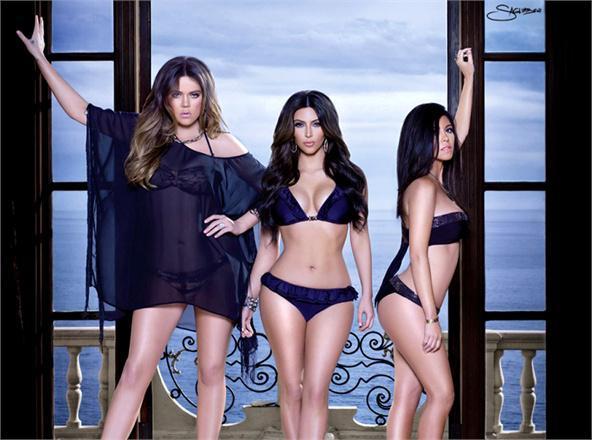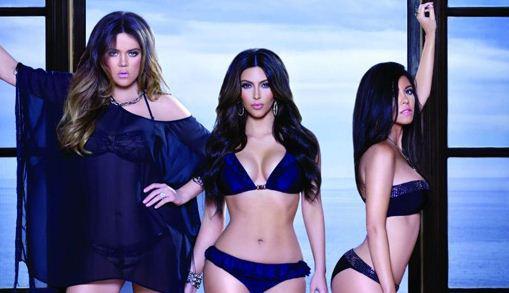The first image is the image on the left, the second image is the image on the right. Examine the images to the left and right. Is the description "A model's bare foot appears in at least one of the images." accurate? Answer yes or no. No. 